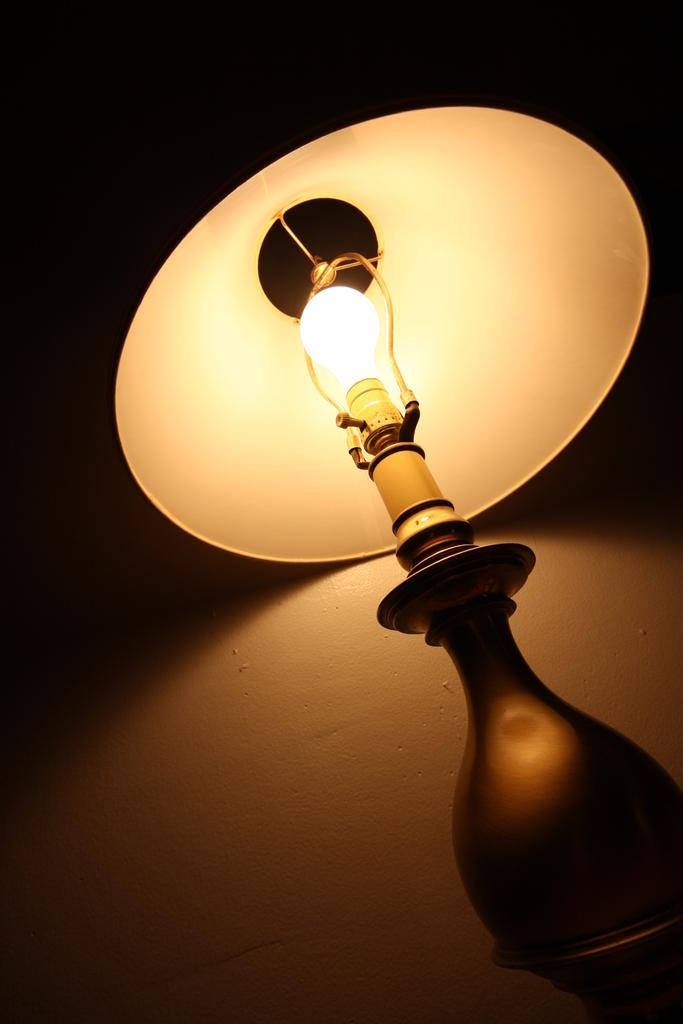What object can be seen in the image that provides light? There is a lamp in the image that provides light. What part of the lamp is responsible for producing light? The lamp has a bulb that is responsible for producing light. How is the bulb connected to the lamp? The bulb is fixed to a socket in the lamp. What is the main structure of the lamp? The lamp has a body that supports the bulb and shade. What is covering the bulb in the image? There is a lamp shade in the image that covers the bulb. How would you describe the overall lighting conditions in the image? The background of the image appears dark. What type of steel is used to make the wax sculpture in the image? There is no wax sculpture present in the image, and therefore no steel is used to make it. 